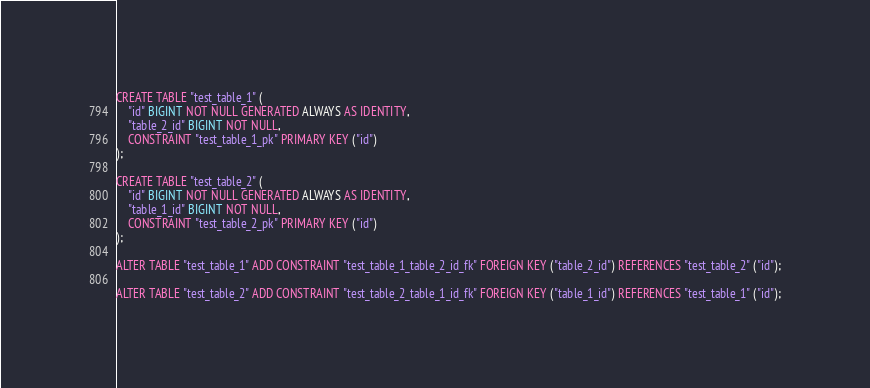Convert code to text. <code><loc_0><loc_0><loc_500><loc_500><_SQL_>CREATE TABLE "test_table_1" (
    "id" BIGINT NOT NULL GENERATED ALWAYS AS IDENTITY,
    "table_2_id" BIGINT NOT NULL,
    CONSTRAINT "test_table_1_pk" PRIMARY KEY ("id")
);

CREATE TABLE "test_table_2" (
    "id" BIGINT NOT NULL GENERATED ALWAYS AS IDENTITY,
    "table_1_id" BIGINT NOT NULL,
    CONSTRAINT "test_table_2_pk" PRIMARY KEY ("id")
);

ALTER TABLE "test_table_1" ADD CONSTRAINT "test_table_1_table_2_id_fk" FOREIGN KEY ("table_2_id") REFERENCES "test_table_2" ("id");

ALTER TABLE "test_table_2" ADD CONSTRAINT "test_table_2_table_1_id_fk" FOREIGN KEY ("table_1_id") REFERENCES "test_table_1" ("id");</code> 